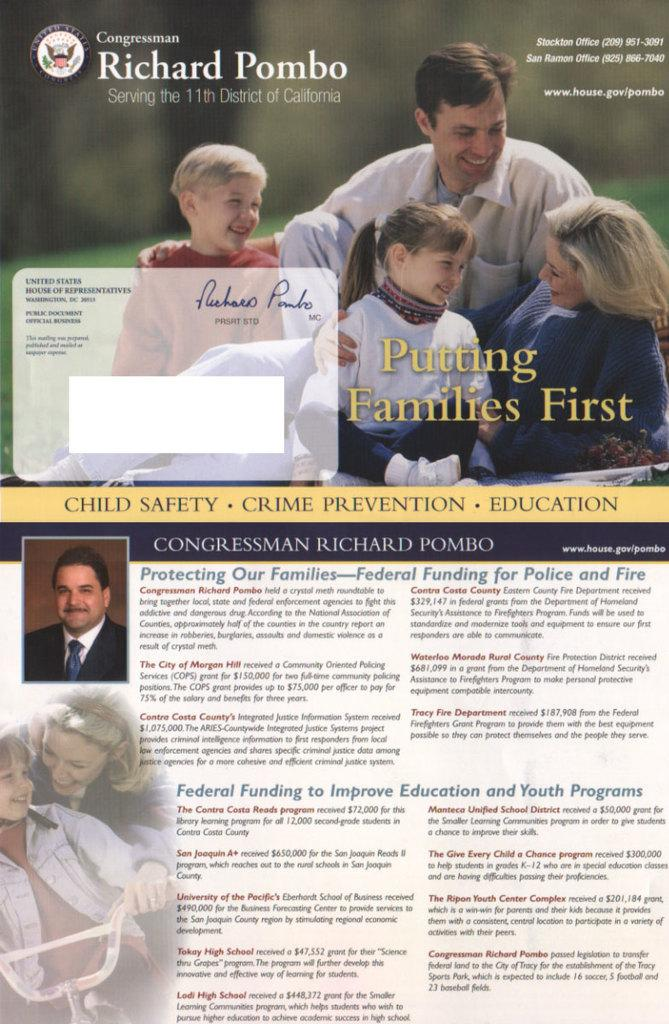What type of content can be found on the brochure in the image? There are photos, words, a logo, a signature, and numbers on the brochure. Can you describe the logo on the brochure? Unfortunately, the specific details of the logo cannot be determined from the image alone. What might the signature on the brochure indicate? The signature on the brochure could indicate authorship, approval, or endorsement. What type of information might be conveyed by the numbers on the brochure? The numbers on the brochure could represent prices, quantities, dates, or other numerical data. What type of bear can be seen hibernating in the winter season in the image? There is no bear or winter season depicted in the image; it features a brochure with various types of content. 